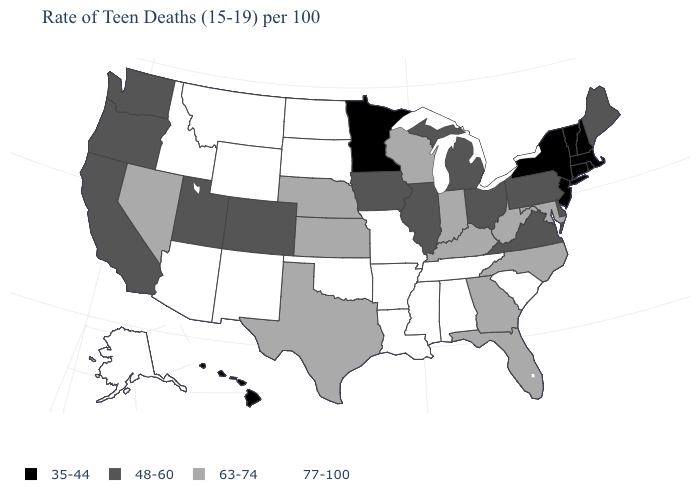Does Delaware have the same value as Pennsylvania?
Keep it brief. Yes. Among the states that border Ohio , does Pennsylvania have the lowest value?
Concise answer only. Yes. What is the value of Maryland?
Answer briefly. 63-74. What is the value of Tennessee?
Keep it brief. 77-100. What is the lowest value in states that border Nebraska?
Write a very short answer. 48-60. Does Minnesota have a lower value than Tennessee?
Give a very brief answer. Yes. Does the map have missing data?
Give a very brief answer. No. Name the states that have a value in the range 63-74?
Write a very short answer. Florida, Georgia, Indiana, Kansas, Kentucky, Maryland, Nebraska, Nevada, North Carolina, Texas, West Virginia, Wisconsin. What is the value of Arkansas?
Short answer required. 77-100. Does the map have missing data?
Concise answer only. No. Which states have the lowest value in the USA?
Be succinct. Connecticut, Hawaii, Massachusetts, Minnesota, New Hampshire, New Jersey, New York, Rhode Island, Vermont. What is the value of Washington?
Quick response, please. 48-60. What is the value of Minnesota?
Give a very brief answer. 35-44. Does Nevada have the lowest value in the West?
Write a very short answer. No. What is the highest value in the USA?
Quick response, please. 77-100. 